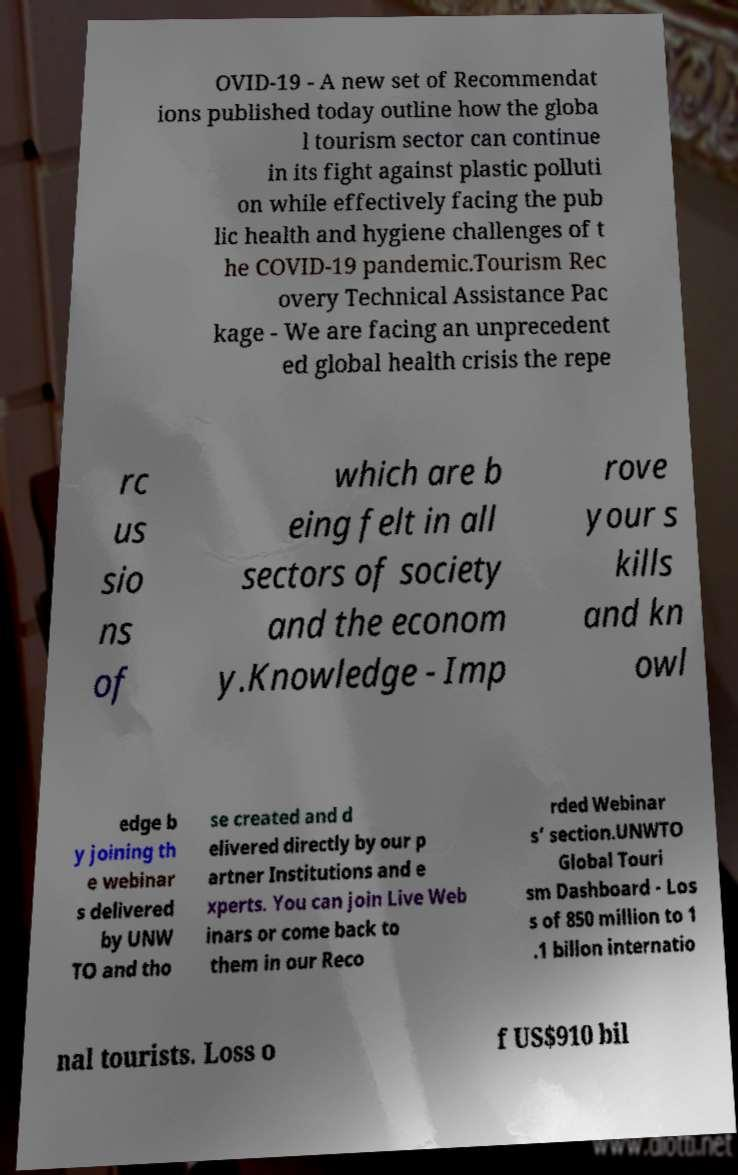Could you assist in decoding the text presented in this image and type it out clearly? OVID-19 - A new set of Recommendat ions published today outline how the globa l tourism sector can continue in its fight against plastic polluti on while effectively facing the pub lic health and hygiene challenges of t he COVID-19 pandemic.Tourism Rec overy Technical Assistance Pac kage - We are facing an unprecedent ed global health crisis the repe rc us sio ns of which are b eing felt in all sectors of society and the econom y.Knowledge - Imp rove your s kills and kn owl edge b y joining th e webinar s delivered by UNW TO and tho se created and d elivered directly by our p artner Institutions and e xperts. You can join Live Web inars or come back to them in our Reco rded Webinar s’ section.UNWTO Global Touri sm Dashboard - Los s of 850 million to 1 .1 billon internatio nal tourists. Loss o f US$910 bil 